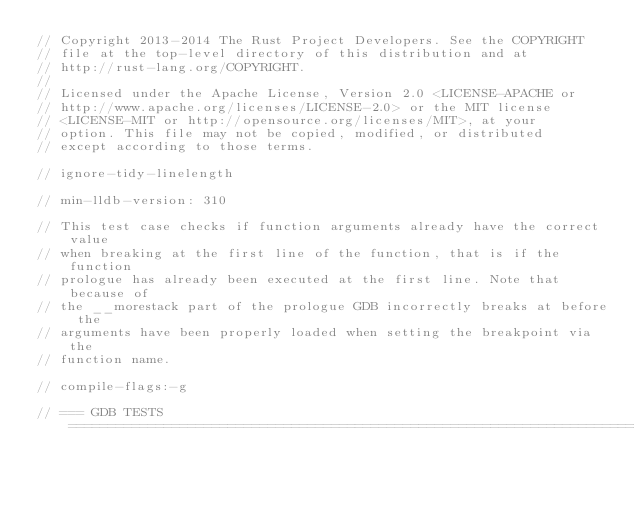Convert code to text. <code><loc_0><loc_0><loc_500><loc_500><_Rust_>// Copyright 2013-2014 The Rust Project Developers. See the COPYRIGHT
// file at the top-level directory of this distribution and at
// http://rust-lang.org/COPYRIGHT.
//
// Licensed under the Apache License, Version 2.0 <LICENSE-APACHE or
// http://www.apache.org/licenses/LICENSE-2.0> or the MIT license
// <LICENSE-MIT or http://opensource.org/licenses/MIT>, at your
// option. This file may not be copied, modified, or distributed
// except according to those terms.

// ignore-tidy-linelength

// min-lldb-version: 310

// This test case checks if function arguments already have the correct value
// when breaking at the first line of the function, that is if the function
// prologue has already been executed at the first line. Note that because of
// the __morestack part of the prologue GDB incorrectly breaks at before the
// arguments have been properly loaded when setting the breakpoint via the
// function name.

// compile-flags:-g

// === GDB TESTS ===================================================================================
</code> 